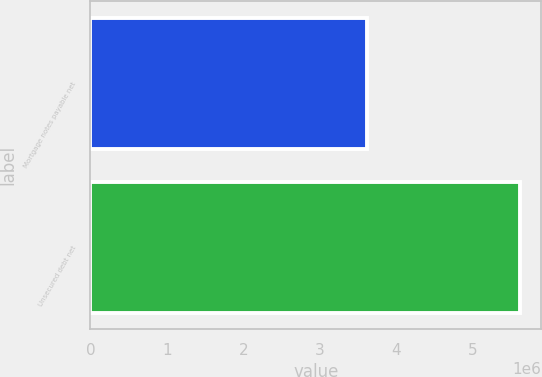<chart> <loc_0><loc_0><loc_500><loc_500><bar_chart><fcel>Mortgage notes payable net<fcel>Unsecured debt net<nl><fcel>3.61538e+06<fcel>5.61974e+06<nl></chart> 